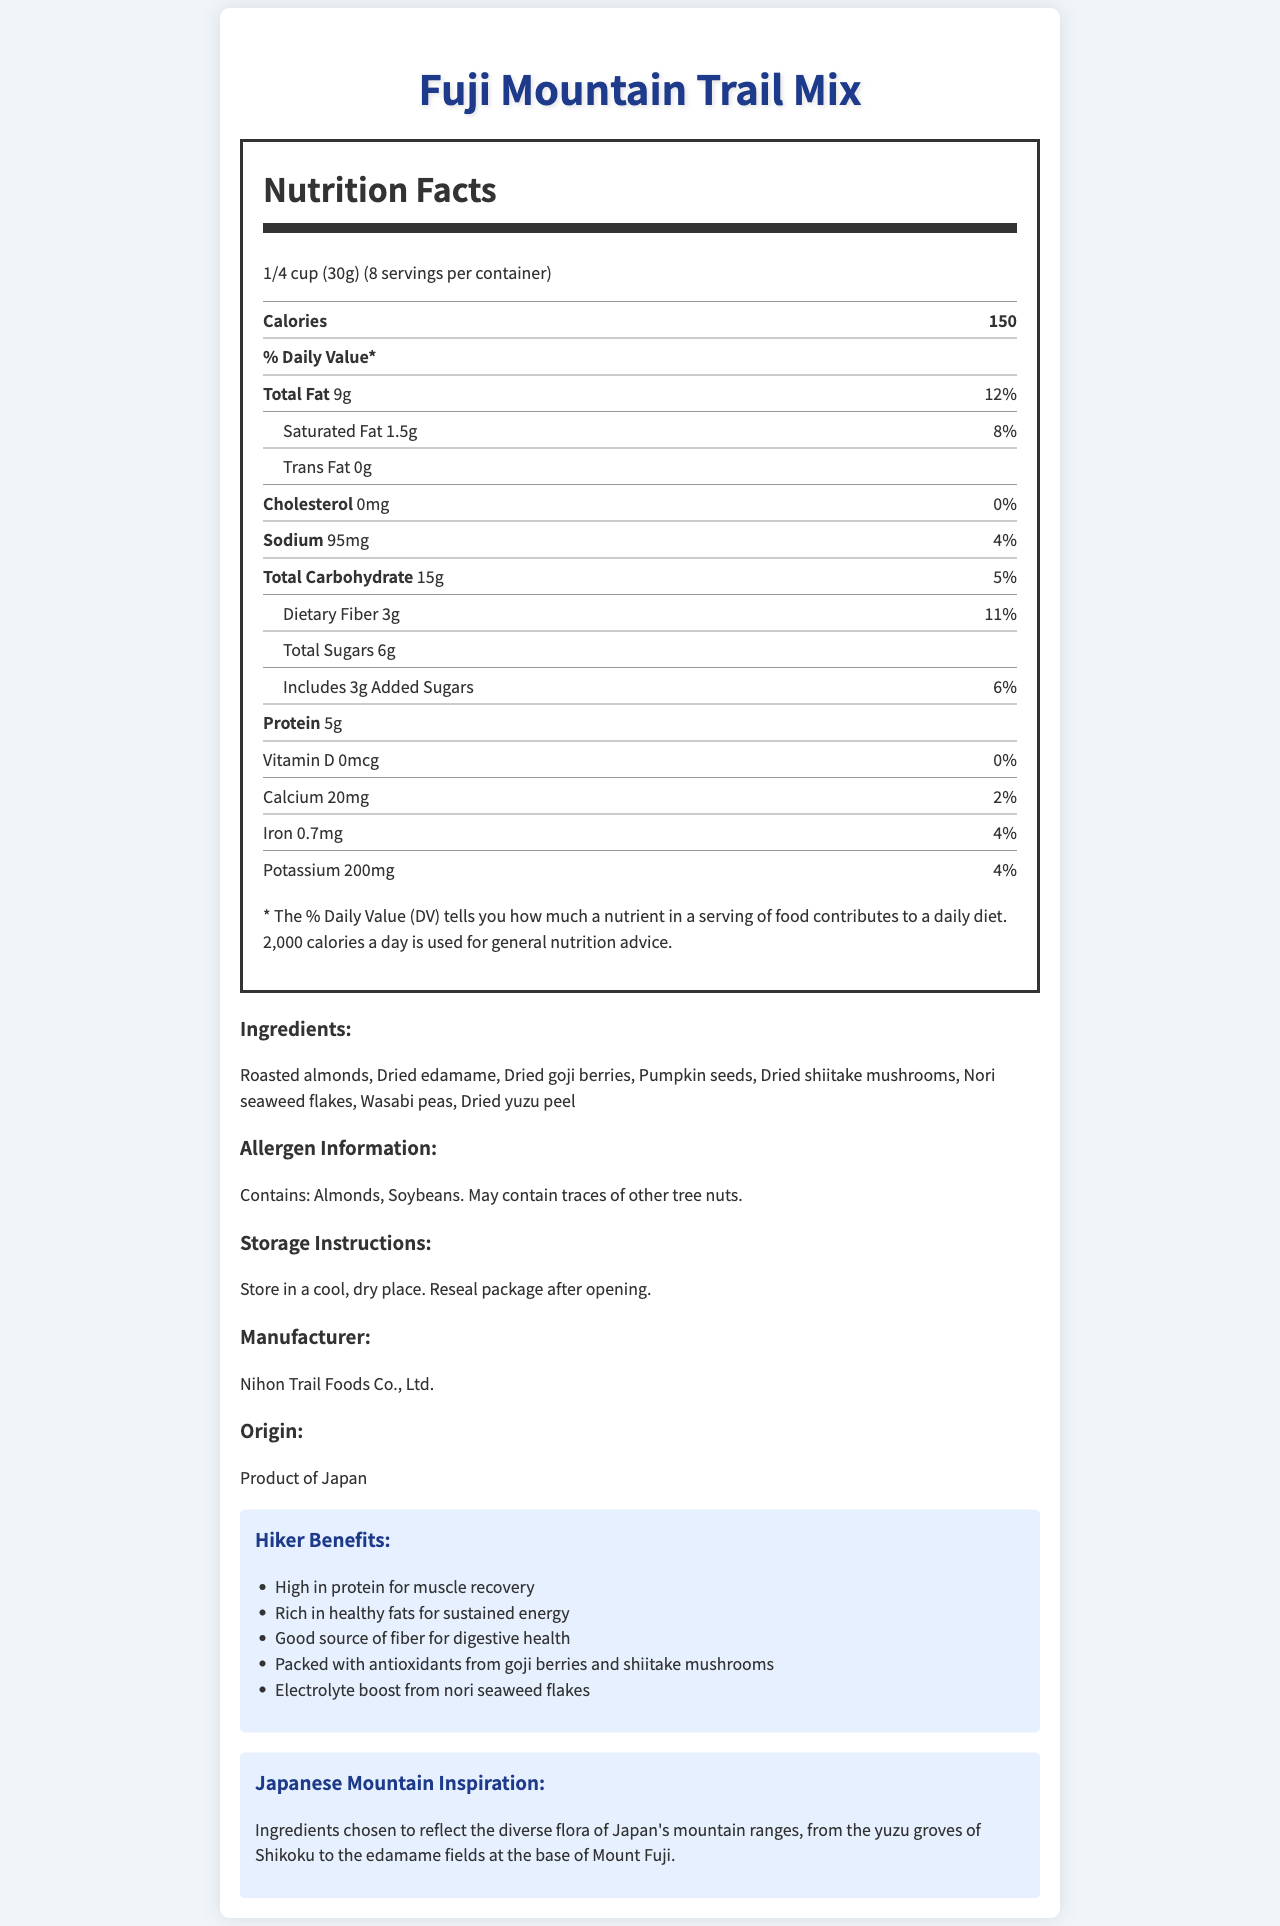what is the serving size of the Fuji Mountain Trail Mix? The serving size is listed as "1/4 cup (30g)" in the nutrition facts section.
Answer: 1/4 cup (30g) how many servings are in the container? The "servings per container" entry specifies that there are 8 servings in the container.
Answer: 8 how many grams of dietary fiber are in one serving? The amount of dietary fiber per serving is listed as 3g in the nutrition facts.
Answer: 3g what are the main ingredients of this trail mix? The ingredients are listed in the ingredients section of the document.
Answer: Roasted almonds, Dried edamame, Dried goji berries, Pumpkin seeds, Dried shiitake mushrooms, Nori seaweed flakes, Wasabi peas, Dried yuzu peel how many calories are there per serving? The calorie count per serving is listed as 150 calories in the nutrition facts.
Answer: 150 which of the following contributes the highest percentage to the daily value based on one serving? A. Vitamin D B. Sodium C. Dietary Fiber D. Calcium Dietary Fiber contributes 11% to the daily value, higher than Sodium (4%), Vitamin D (0%), and Calcium (2%).
Answer: C. Dietary Fiber how much total fat is in one serving? A. 7g B. 9g C. 12g D. 15g The total fat content per serving is listed as 9g in the nutrition facts.
Answer: B. 9g is there any cholesterol in the Fuji Mountain Trail Mix? The nutrition facts label clearly indicates that the cholesterol amount is 0mg, implying there is no cholesterol.
Answer: No describe the hiker benefits of this trail mix The hiker benefits section lists these specific advantages provided by the trail mix.
Answer: The trail mix is high in protein for muscle recovery, rich in healthy fats for sustained energy, a good source of fiber for digestive health, packed with antioxidants from goji berries and shiitake mushrooms, and provides an electrolyte boost from nori seaweed flakes. what is the inspiration behind the ingredients selection for this trail mix? The Japanese Mountain Inspiration section explains that the ingredients reflect the diverse flora of Japan's mountain ranges.
Answer: Ingredients chosen to reflect the diverse flora of Japan's mountain ranges, from the yuzu groves of Shikoku to the edamame fields at the base of Mount Fuji. how much sodium is there in one serving? The amount of sodium per serving is listed as 95mg in the nutrition facts.
Answer: 95mg does the Fuji Mountain Trail Mix contain any trans fat? The nutrition facts label indicates that the trans fat amount is 0g.
Answer: No summarize the main idea of the document The document includes detailed information on the nutritional content, ingredients, and other essential details about Fuji Mountain Trail Mix, focusing on its benefits for hikers and its Japanese mountain-inspired ingredients.
Answer: The document provides a detailed nutrition facts label for Fuji Mountain Trail Mix, highlighting its serving size, ingredients, allergen information, storage instructions, manufacturer details, and origin. It also emphasizes the health benefits for hikers and the inspiration behind using Japanese mountain-inspired ingredients. who is the target audience for the hiking benefits mentioned in the document? The hiking benefits section lists specific advantages like muscle recovery and sustained energy, which are particularly relevant to people who hike or engage in outdoor activities.
Answer: Avid hikers and outdoor enthusiasts what is the amount of added sugars per serving? The nutrition facts indicate that there are 3g of added sugars per serving.
Answer: 3g is the Fuji Mountain Trail Mix a good source of vitamin D? The nutrition facts label shows that the amount of vitamin D is 0mcg, contributing 0% to the daily value.
Answer: No how are the ingredients chosen to reflect Japanese mountain inspiration? The Japanese Mountain Inspiration section states that the ingredients were chosen to represent the diverse flora of Japan's mountain regions.
Answer: Ingredients are selected to reflect the diverse flora of Japan's mountain ranges, such as yuzu groves of Shikoku and edamame fields at the base of Mount Fuji. 